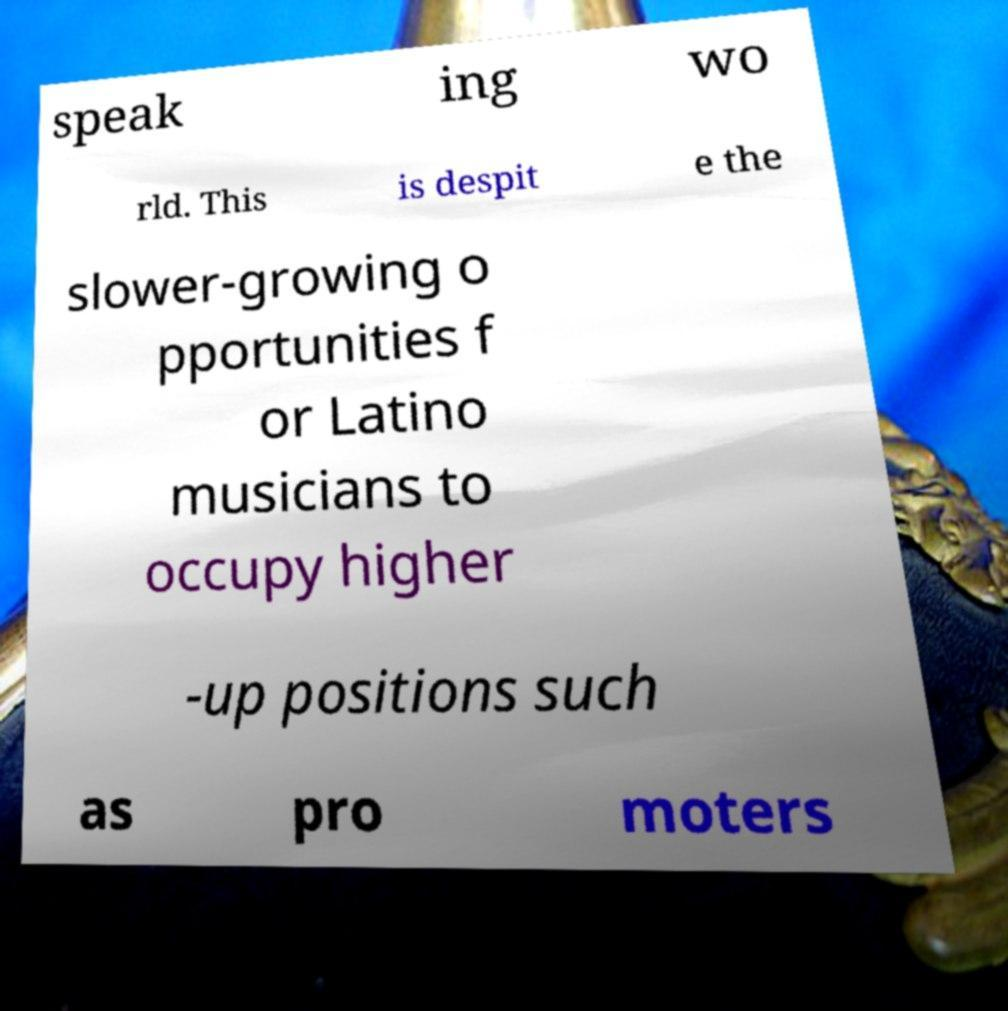Please read and relay the text visible in this image. What does it say? speak ing wo rld. This is despit e the slower-growing o pportunities f or Latino musicians to occupy higher -up positions such as pro moters 